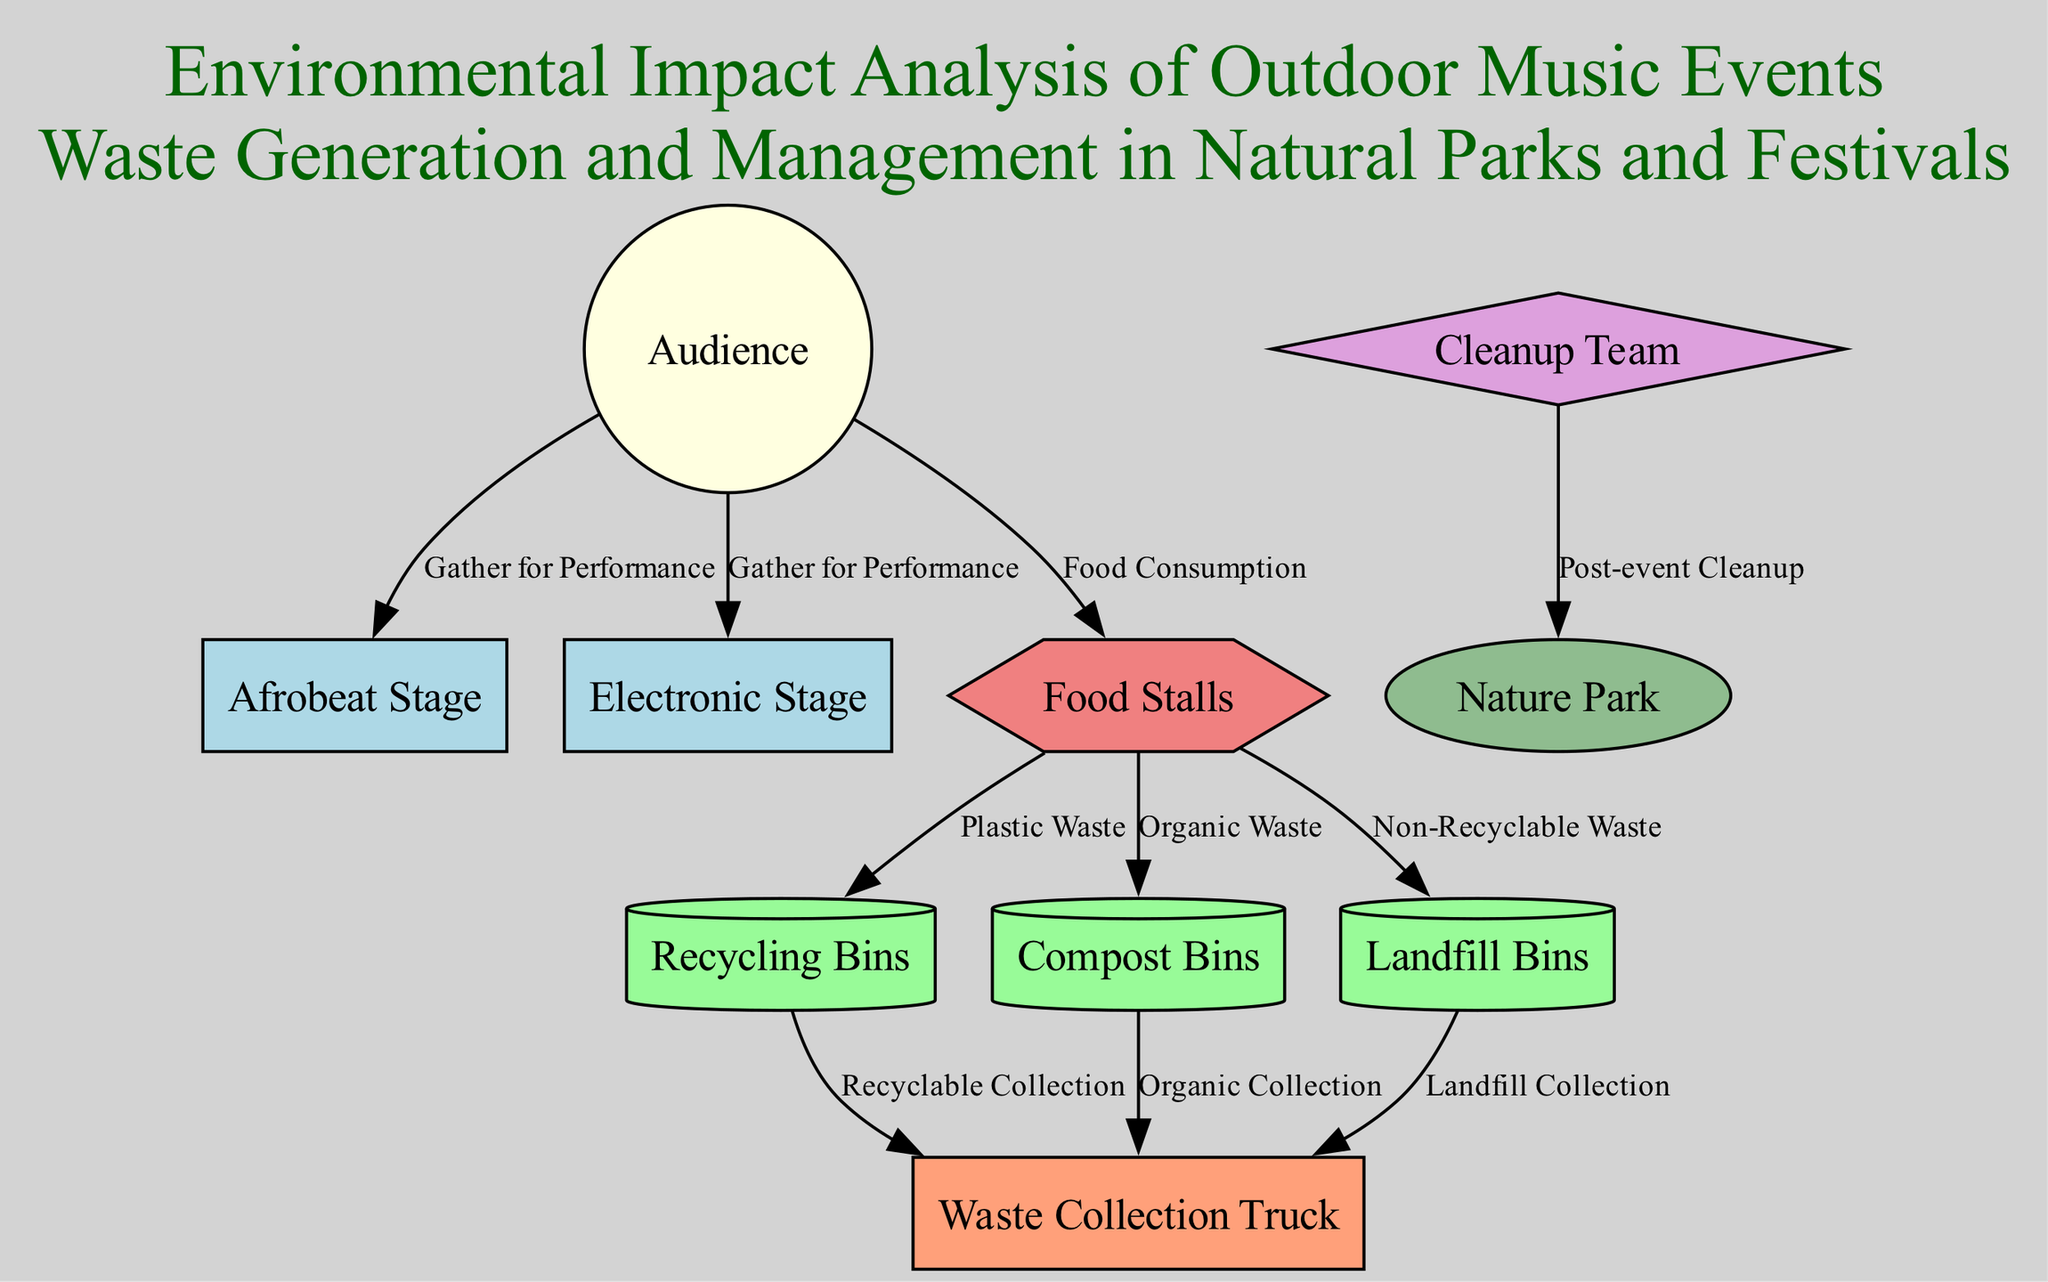What is the main subject of the diagram? The title in the diagram indicates that the main subject is the "Environmental Impact Analysis of Outdoor Music Events". This is confirmed by looking at the first annotation in the provided data.
Answer: Environmental Impact Analysis of Outdoor Music Events How many performance areas are shown in the diagram? By reviewing the nodes in the diagram, there are two performance areas listed: Afrobeat Stage and Electronic Stage. Counting them gives a total of two.
Answer: 2 What type of waste management bins are connected to food stalls? Three types of waste management bins are directly connected to food stalls: Recycling Bins, Compost Bins, and Landfill Bins. These connections are evident in the edges leading from food stalls.
Answer: Recycling Bins, Compost Bins, Landfill Bins What is the role of the cleanup team in this diagram? The cleanup team is connected to the nature park with the label "Post-event Cleanup". This indicates that the cleanup team's responsibility is to clean up the area after the event concludes.
Answer: Post-event Cleanup How does the audience interact with food stalls? The audience is labeled to interact with food stalls through "Food Consumption", which is directly indicated by the edge connecting these two nodes. This shows that food stalls serve food to the audience.
Answer: Food Consumption What happens to recyclable materials after being placed in recycling bins? The recycling bins are connected to the waste collection truck with the label "Recyclable Collection", indicating that recyclable materials are collected and transported away by the waste collection truck.
Answer: Recyclable Collection Which waste management facilities do organic wastes go to? Organic wastes go to compost bins, which are then connected to the waste collection truck through the edge labeled "Organic Collection". This demonstrates the flow from organic waste to collection.
Answer: Compost Bins How many types of facilities are present in the diagram? There is one type of facility shown, which is Food Stalls. The diagram lists only this facility type with no others mentioned.
Answer: 1 